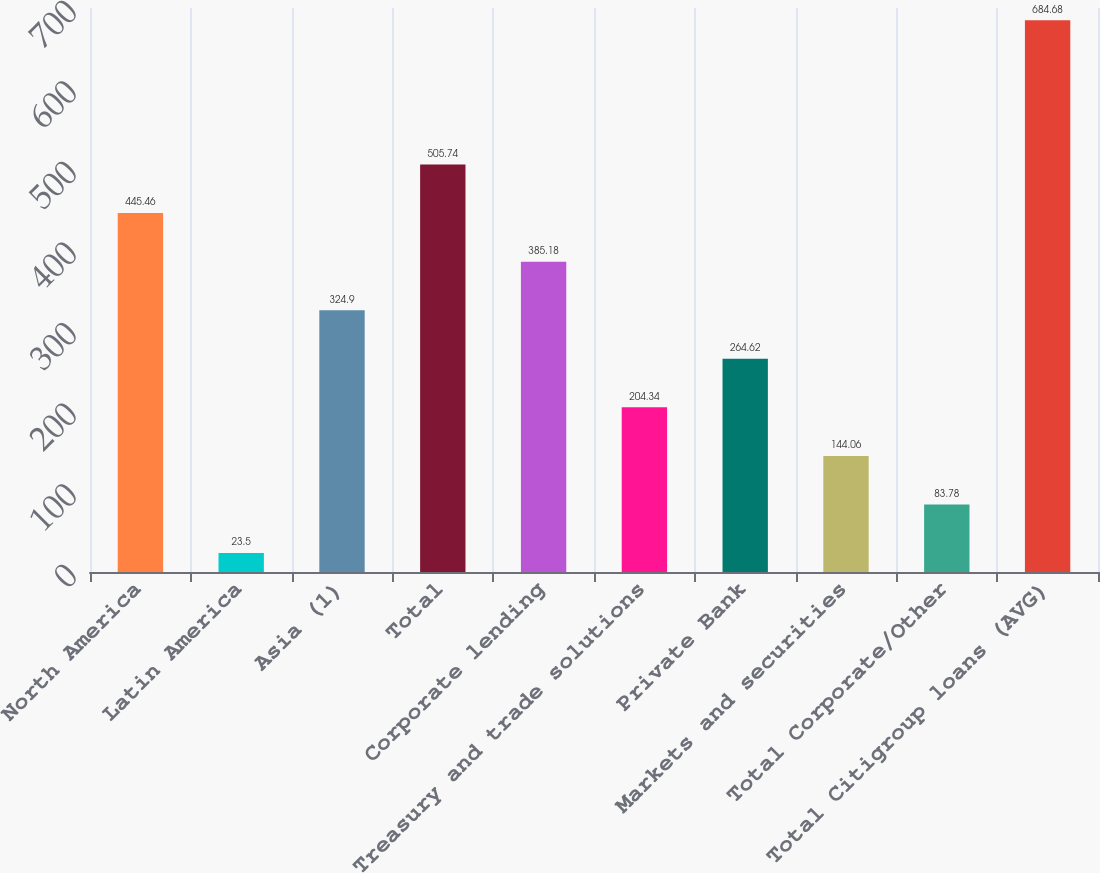Convert chart. <chart><loc_0><loc_0><loc_500><loc_500><bar_chart><fcel>North America<fcel>Latin America<fcel>Asia (1)<fcel>Total<fcel>Corporate lending<fcel>Treasury and trade solutions<fcel>Private Bank<fcel>Markets and securities<fcel>Total Corporate/Other<fcel>Total Citigroup loans (AVG)<nl><fcel>445.46<fcel>23.5<fcel>324.9<fcel>505.74<fcel>385.18<fcel>204.34<fcel>264.62<fcel>144.06<fcel>83.78<fcel>684.68<nl></chart> 